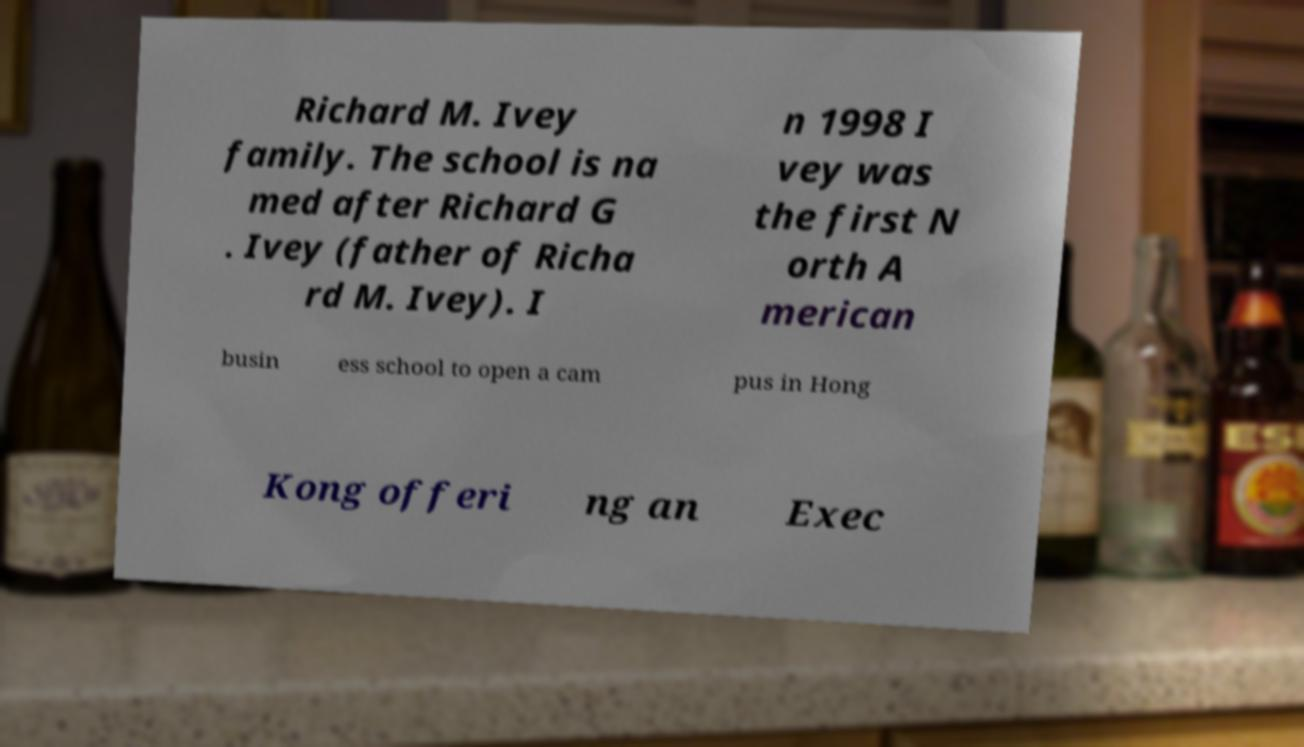For documentation purposes, I need the text within this image transcribed. Could you provide that? Richard M. Ivey family. The school is na med after Richard G . Ivey (father of Richa rd M. Ivey). I n 1998 I vey was the first N orth A merican busin ess school to open a cam pus in Hong Kong offeri ng an Exec 